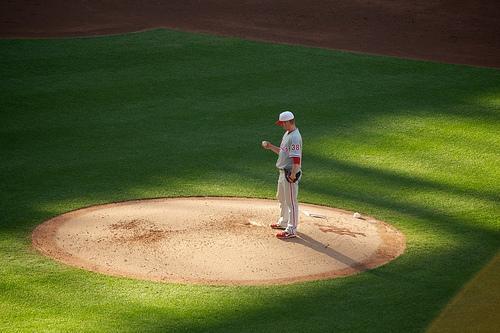How many balls are there?
Give a very brief answer. 2. 